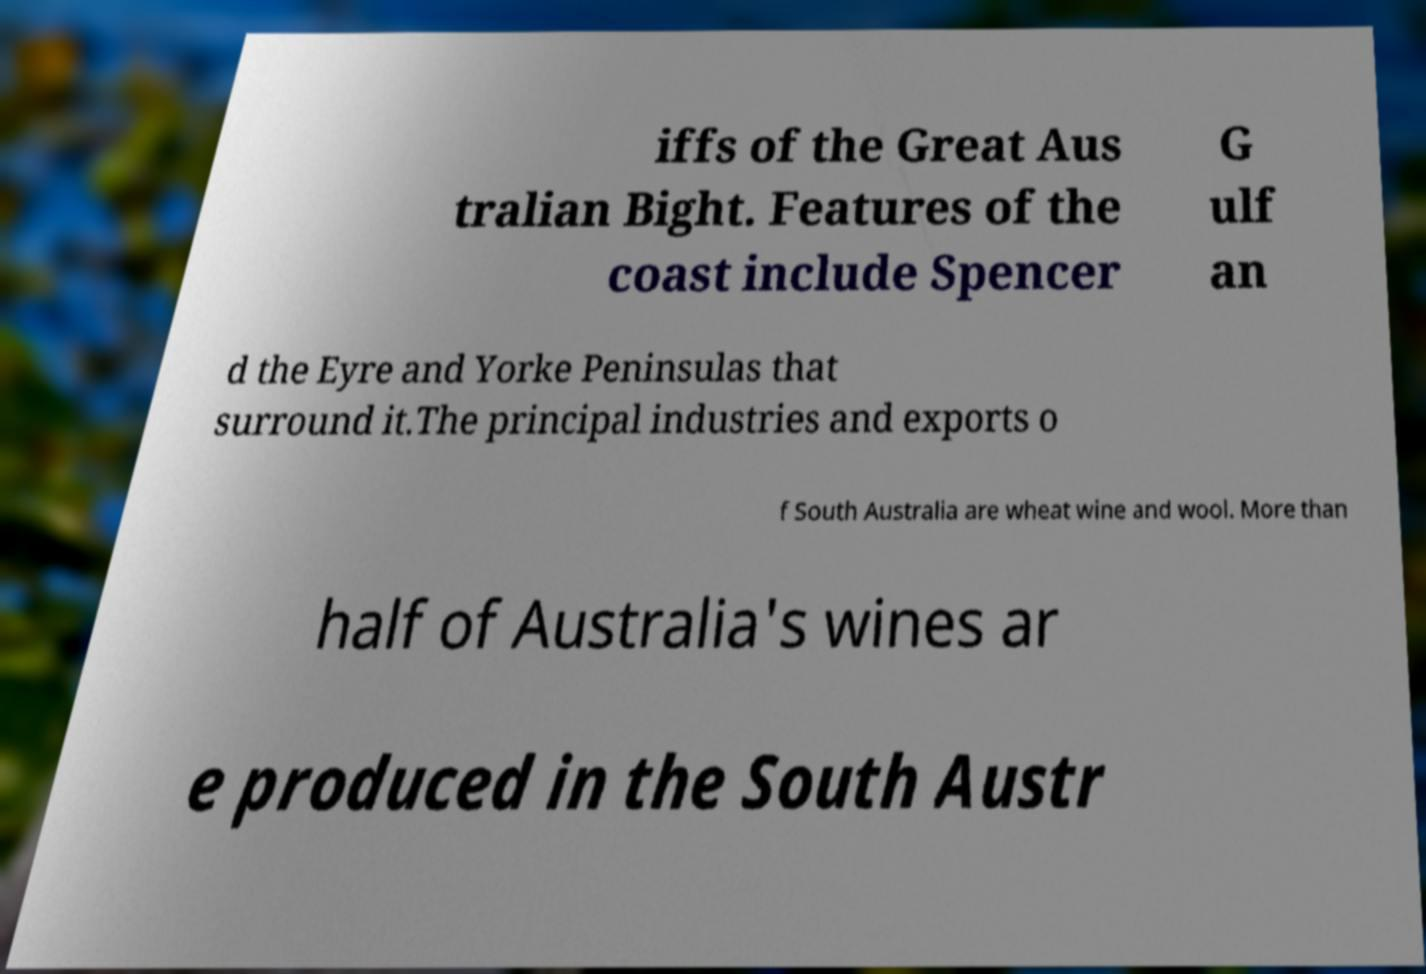Please read and relay the text visible in this image. What does it say? iffs of the Great Aus tralian Bight. Features of the coast include Spencer G ulf an d the Eyre and Yorke Peninsulas that surround it.The principal industries and exports o f South Australia are wheat wine and wool. More than half of Australia's wines ar e produced in the South Austr 